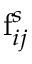<formula> <loc_0><loc_0><loc_500><loc_500>f _ { i j } ^ { s }</formula> 